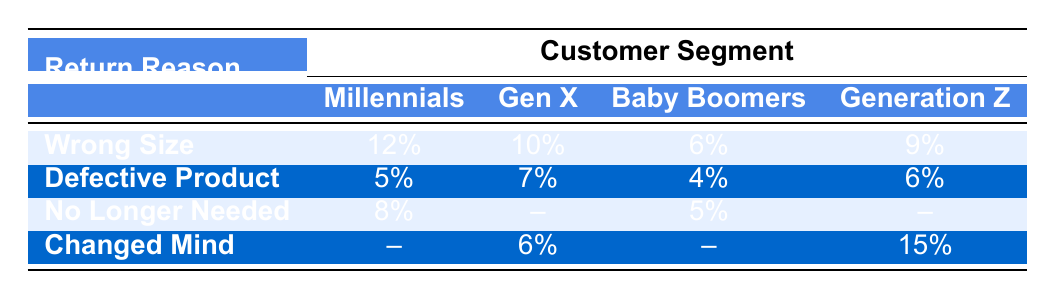What is the return rate for Millennials due to the reason "Wrong Size"? The table indicates a return rate of 12% for Millennials under the reason "Wrong Size".
Answer: 12% What is the return rate for Baby Boomers when they do not need the product anymore? The return rate for Baby Boomers listed in the table under "No Longer Needed" is 5%.
Answer: 5% Is there a return rate for Gen X under the reason "No Longer Needed"? The table shows that there is no return rate listed for Gen X under "No Longer Needed", which is indicated by a dash (–).
Answer: No What is the highest return rate among all the segments for the reason "Changed Mind"? Looking at the table, the highest return rate for "Changed Mind" is 15%, which is attributed to Generation Z.
Answer: 15% What is the average return rate for the reason "Defective Product" across all customer segments? The return rates for "Defective Product" are 5% (Millennials), 7% (Gen X), 4% (Baby Boomers), and 6% (Generation Z). The average is (5 + 7 + 4 + 6) / 4 = 5.5%.
Answer: 5.5% Are Millennials more likely than Baby Boomers to return products due to "Wrong Size"? The table shows that Millennials have a return rate of 12% for "Wrong Size", while Baby Boomers have a return rate of 6%. Since 12% is greater than 6%, it is true that Millennials are more likely.
Answer: Yes Which customer segment has the lowest return rate for the reason "Defective Product"? The table shows return rates for "Defective Product" as 5% for Millennials, 7% for Gen X, 4% for Baby Boomers, and 6% for Generation Z. The lowest return rate is 4% for Baby Boomers.
Answer: 4% What is the difference in return rates due to "Wrong Size" between Generation Z and Gen X? The return rate for Generation Z is 9% and for Gen X it is 10%. The difference is 10% - 9% = 1%.
Answer: 1% For which reason do Millennials have a higher return rate than Baby Boomers? Millennials have higher return rates than Baby Boomers for "Wrong Size" at 12% vs 6% and "Defective Product" at 5% vs 4%. Therefore, both reasons show higher rates for Millennials compared to Baby Boomers.
Answer: Wrong Size and Defective Product 